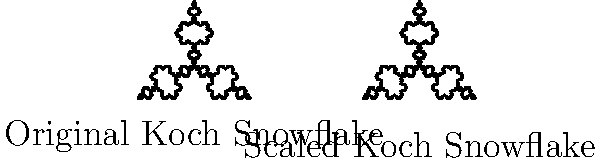Consider the Koch snowflake fractal shown in the image. If we scale the entire fractal by a factor of $\frac{1}{2}$, how does this transformation affect the fractal's self-similarity property? Specifically, how many iterations of the original Koch snowflake construction process would be needed to produce a shape equivalent to the scaled version? To answer this question, let's consider the properties of the Koch snowflake and the effects of scaling:

1. The Koch snowflake is a self-similar fractal, meaning that each part of the fractal is a scaled-down copy of the whole.

2. Each iteration of the Koch snowflake construction process increases the level of detail by a factor of 3. That is, each straight line segment is replaced by four smaller segments, each $\frac{1}{3}$ the length of the original.

3. When we scale the entire fractal by $\frac{1}{2}$, we're effectively reducing the size of each segment by half.

4. To determine how many iterations are needed to produce a shape equivalent to the scaled version, we need to find how many times we need to divide by 3 to get $\frac{1}{2}$:

   $$\left(\frac{1}{3}\right)^n = \frac{1}{2}$$

5. Taking the logarithm of both sides:

   $$n \log\left(\frac{1}{3}\right) = \log\left(\frac{1}{2}\right)$$

6. Solving for $n$:

   $$n = \frac{\log\left(\frac{1}{2}\right)}{\log\left(\frac{1}{3}\right)} \approx 0.6309$$

7. Since we can only have a whole number of iterations, we round up to the nearest integer.

Therefore, one additional iteration of the original Koch snowflake construction process would be needed to produce a shape with more detail than the scaled version, effectively maintaining the self-similarity property.
Answer: 1 additional iteration 